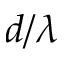<formula> <loc_0><loc_0><loc_500><loc_500>d / \lambda</formula> 